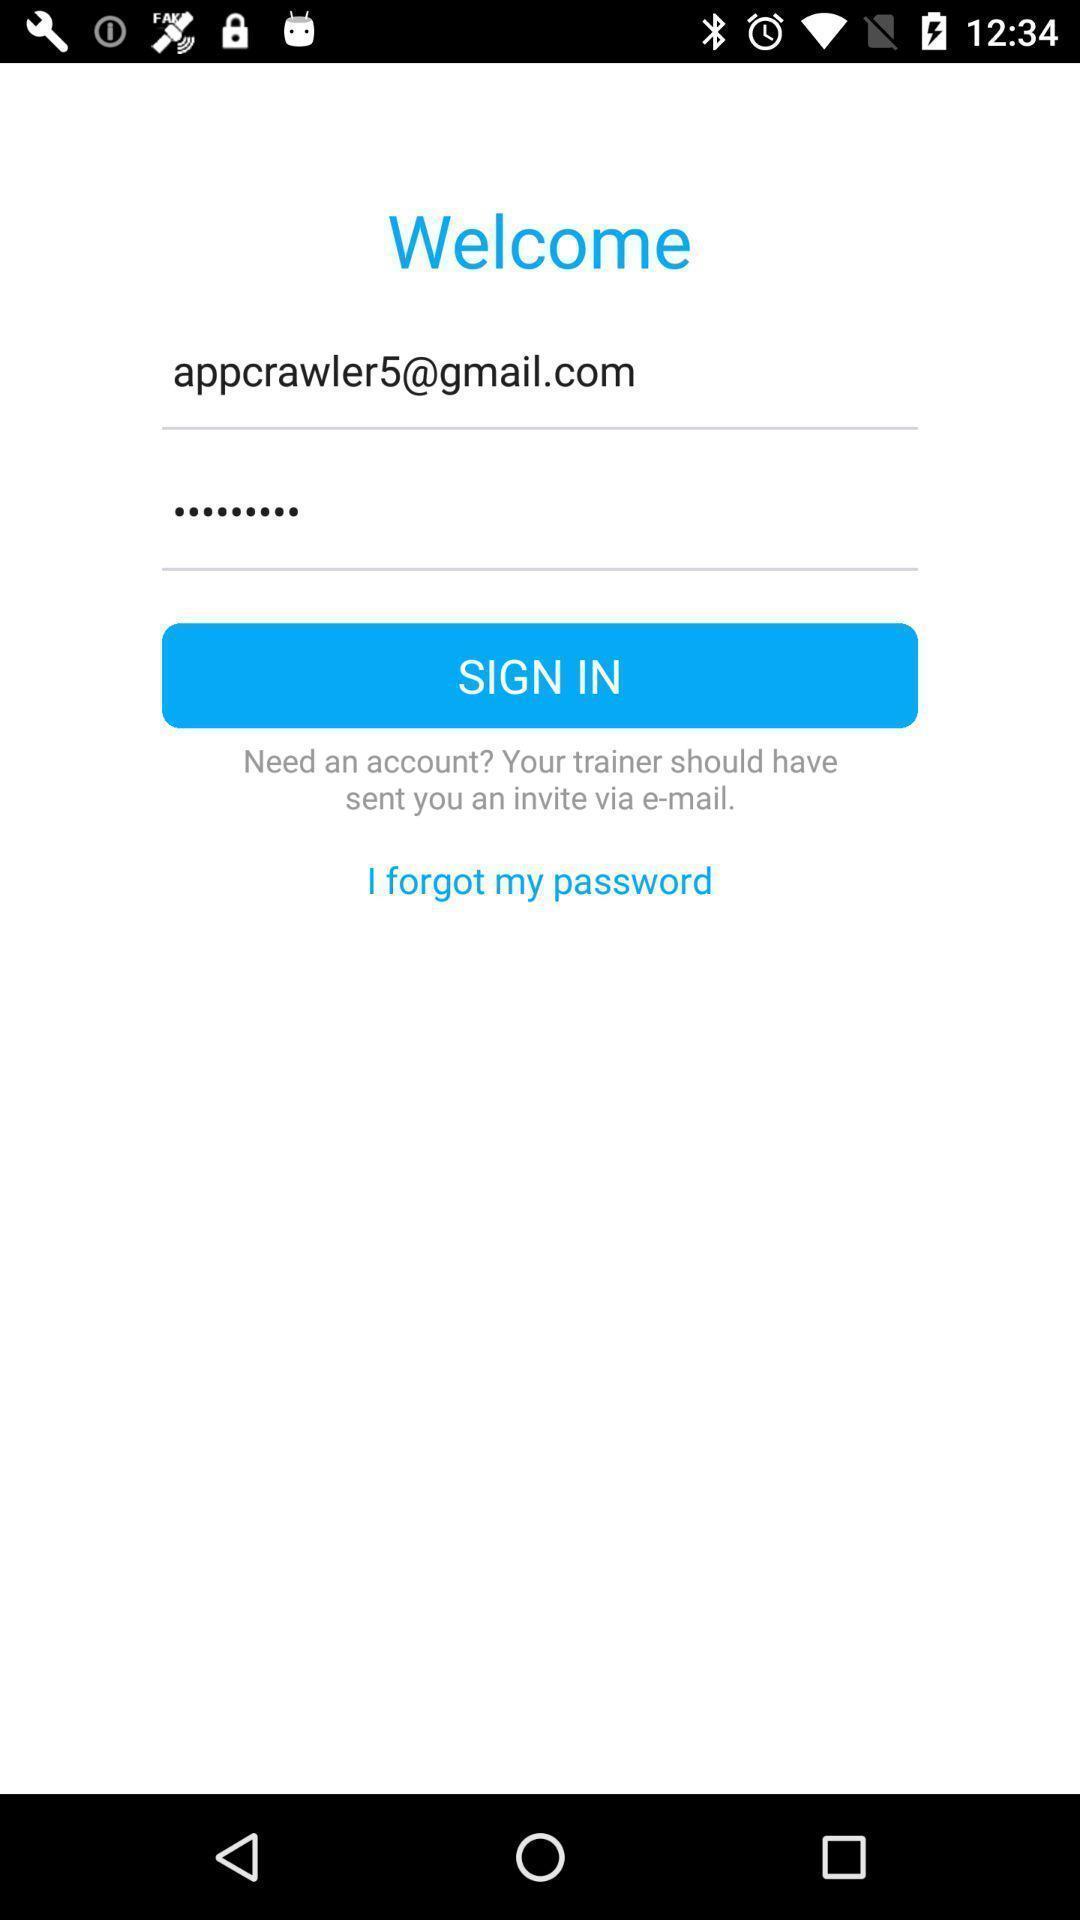Explain what's happening in this screen capture. Welcome page. 